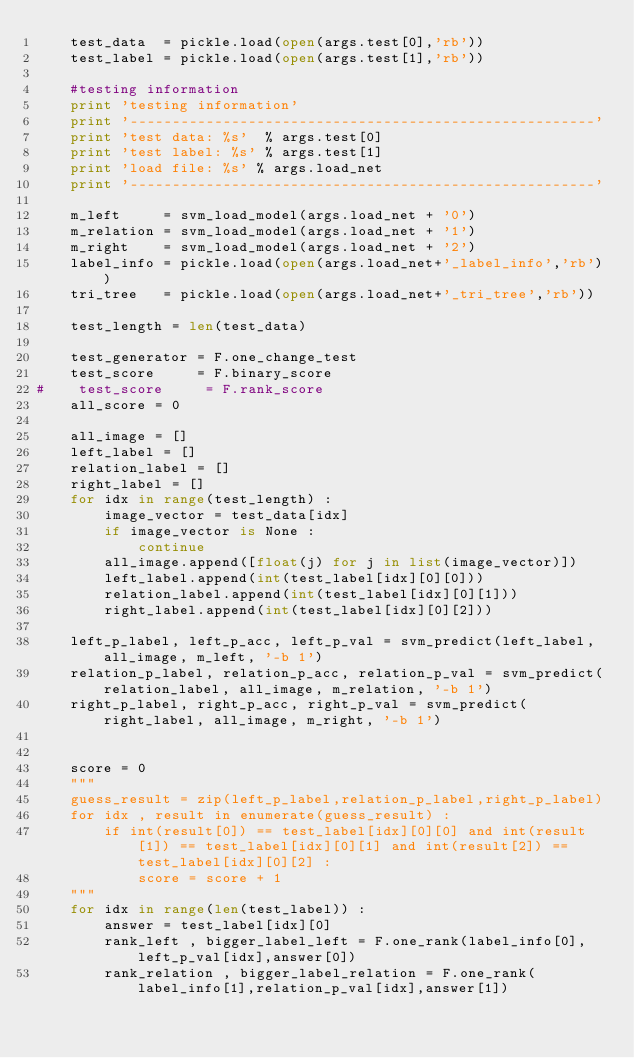Convert code to text. <code><loc_0><loc_0><loc_500><loc_500><_Python_>    test_data  = pickle.load(open(args.test[0],'rb'))
    test_label = pickle.load(open(args.test[1],'rb'))

    #testing information
    print 'testing information'
    print '-------------------------------------------------------'
    print 'test data: %s'  % args.test[0]
    print 'test label: %s' % args.test[1]
    print 'load file: %s' % args.load_net
    print '-------------------------------------------------------'

    m_left     = svm_load_model(args.load_net + '0')
    m_relation = svm_load_model(args.load_net + '1')
    m_right    = svm_load_model(args.load_net + '2')
    label_info = pickle.load(open(args.load_net+'_label_info','rb'))
    tri_tree   = pickle.load(open(args.load_net+'_tri_tree','rb'))

    test_length = len(test_data)

    test_generator = F.one_change_test
    test_score     = F.binary_score
#    test_score     = F.rank_score
    all_score = 0

    all_image = []
    left_label = []
    relation_label = []
    right_label = []
    for idx in range(test_length) :
        image_vector = test_data[idx]
        if image_vector is None :
            continue
        all_image.append([float(j) for j in list(image_vector)])
        left_label.append(int(test_label[idx][0][0]))
        relation_label.append(int(test_label[idx][0][1]))
        right_label.append(int(test_label[idx][0][2]))

    left_p_label, left_p_acc, left_p_val = svm_predict(left_label, all_image, m_left, '-b 1') 
    relation_p_label, relation_p_acc, relation_p_val = svm_predict(relation_label, all_image, m_relation, '-b 1') 
    right_p_label, right_p_acc, right_p_val = svm_predict(right_label, all_image, m_right, '-b 1') 


    score = 0
    """       
    guess_result = zip(left_p_label,relation_p_label,right_p_label) 
    for idx , result in enumerate(guess_result) :
        if int(result[0]) == test_label[idx][0][0] and int(result[1]) == test_label[idx][0][1] and int(result[2]) == test_label[idx][0][2] :
            score = score + 1
    """
    for idx in range(len(test_label)) :
        answer = test_label[idx][0]
        rank_left , bigger_label_left = F.one_rank(label_info[0],left_p_val[idx],answer[0])
        rank_relation , bigger_label_relation = F.one_rank(label_info[1],relation_p_val[idx],answer[1])</code> 